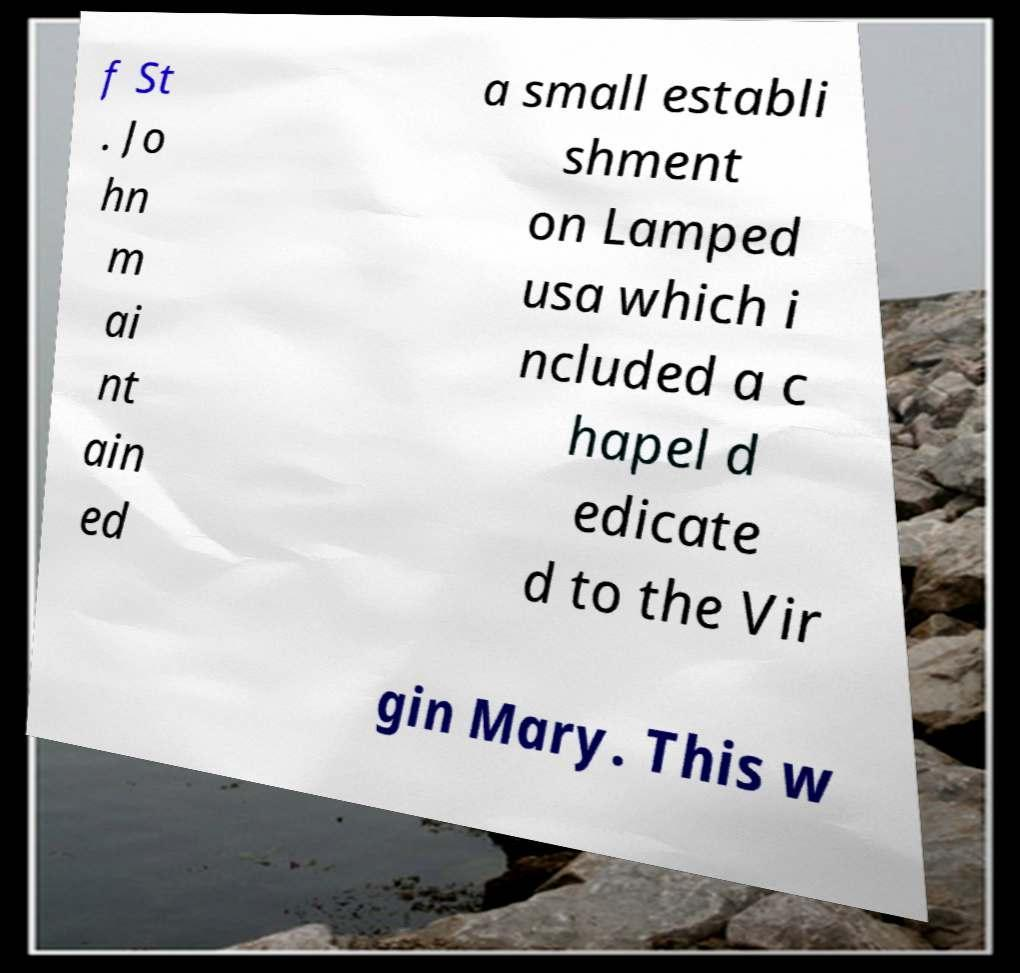Can you accurately transcribe the text from the provided image for me? f St . Jo hn m ai nt ain ed a small establi shment on Lamped usa which i ncluded a c hapel d edicate d to the Vir gin Mary. This w 